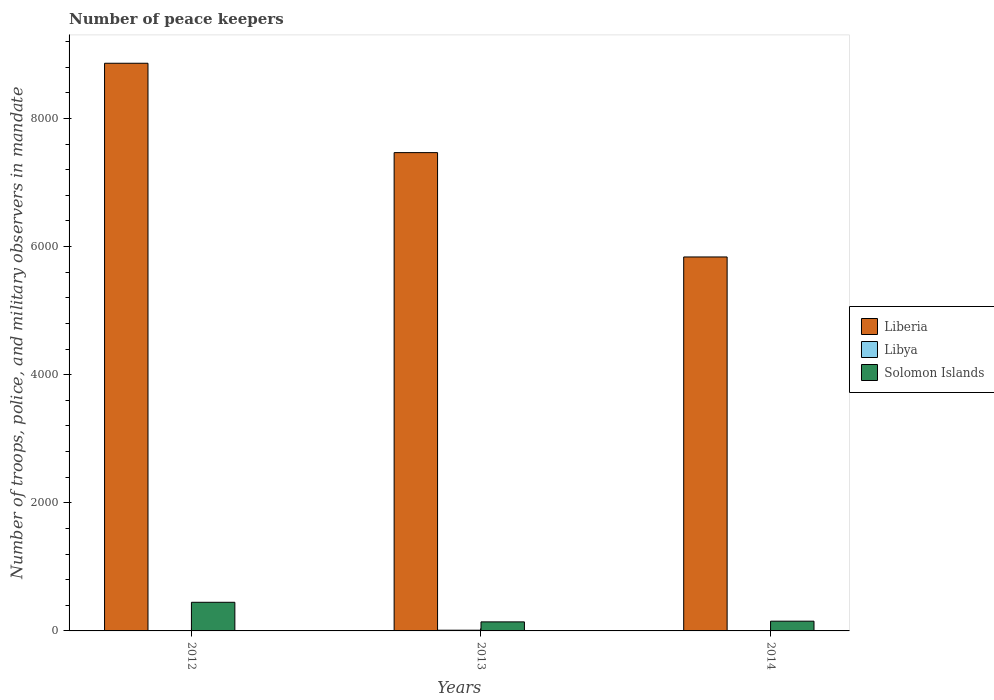How many different coloured bars are there?
Keep it short and to the point. 3. What is the number of peace keepers in in Solomon Islands in 2013?
Make the answer very short. 141. Across all years, what is the maximum number of peace keepers in in Solomon Islands?
Your answer should be very brief. 447. Across all years, what is the minimum number of peace keepers in in Libya?
Provide a succinct answer. 2. What is the total number of peace keepers in in Solomon Islands in the graph?
Your answer should be compact. 740. What is the difference between the number of peace keepers in in Liberia in 2012 and that in 2013?
Keep it short and to the point. 1395. What is the difference between the number of peace keepers in in Liberia in 2012 and the number of peace keepers in in Solomon Islands in 2013?
Give a very brief answer. 8721. What is the average number of peace keepers in in Solomon Islands per year?
Offer a terse response. 246.67. In the year 2012, what is the difference between the number of peace keepers in in Libya and number of peace keepers in in Liberia?
Keep it short and to the point. -8860. What is the ratio of the number of peace keepers in in Liberia in 2012 to that in 2013?
Offer a very short reply. 1.19. Is the number of peace keepers in in Libya in 2012 less than that in 2013?
Give a very brief answer. Yes. Is the difference between the number of peace keepers in in Libya in 2012 and 2013 greater than the difference between the number of peace keepers in in Liberia in 2012 and 2013?
Your answer should be very brief. No. What is the difference between the highest and the lowest number of peace keepers in in Solomon Islands?
Give a very brief answer. 306. In how many years, is the number of peace keepers in in Solomon Islands greater than the average number of peace keepers in in Solomon Islands taken over all years?
Provide a short and direct response. 1. Is the sum of the number of peace keepers in in Libya in 2013 and 2014 greater than the maximum number of peace keepers in in Solomon Islands across all years?
Provide a short and direct response. No. What does the 1st bar from the left in 2014 represents?
Give a very brief answer. Liberia. What does the 1st bar from the right in 2014 represents?
Your response must be concise. Solomon Islands. Is it the case that in every year, the sum of the number of peace keepers in in Liberia and number of peace keepers in in Libya is greater than the number of peace keepers in in Solomon Islands?
Offer a terse response. Yes. How many bars are there?
Offer a terse response. 9. Are all the bars in the graph horizontal?
Provide a succinct answer. No. How many years are there in the graph?
Offer a very short reply. 3. Does the graph contain any zero values?
Your answer should be compact. No. How many legend labels are there?
Offer a terse response. 3. What is the title of the graph?
Your answer should be very brief. Number of peace keepers. Does "Saudi Arabia" appear as one of the legend labels in the graph?
Offer a terse response. No. What is the label or title of the X-axis?
Offer a terse response. Years. What is the label or title of the Y-axis?
Ensure brevity in your answer.  Number of troops, police, and military observers in mandate. What is the Number of troops, police, and military observers in mandate in Liberia in 2012?
Make the answer very short. 8862. What is the Number of troops, police, and military observers in mandate of Solomon Islands in 2012?
Provide a short and direct response. 447. What is the Number of troops, police, and military observers in mandate in Liberia in 2013?
Your response must be concise. 7467. What is the Number of troops, police, and military observers in mandate of Solomon Islands in 2013?
Provide a short and direct response. 141. What is the Number of troops, police, and military observers in mandate in Liberia in 2014?
Offer a very short reply. 5838. What is the Number of troops, police, and military observers in mandate in Libya in 2014?
Your answer should be compact. 2. What is the Number of troops, police, and military observers in mandate in Solomon Islands in 2014?
Ensure brevity in your answer.  152. Across all years, what is the maximum Number of troops, police, and military observers in mandate in Liberia?
Make the answer very short. 8862. Across all years, what is the maximum Number of troops, police, and military observers in mandate of Solomon Islands?
Give a very brief answer. 447. Across all years, what is the minimum Number of troops, police, and military observers in mandate in Liberia?
Make the answer very short. 5838. Across all years, what is the minimum Number of troops, police, and military observers in mandate of Solomon Islands?
Offer a terse response. 141. What is the total Number of troops, police, and military observers in mandate in Liberia in the graph?
Provide a succinct answer. 2.22e+04. What is the total Number of troops, police, and military observers in mandate of Solomon Islands in the graph?
Your response must be concise. 740. What is the difference between the Number of troops, police, and military observers in mandate of Liberia in 2012 and that in 2013?
Give a very brief answer. 1395. What is the difference between the Number of troops, police, and military observers in mandate in Libya in 2012 and that in 2013?
Keep it short and to the point. -9. What is the difference between the Number of troops, police, and military observers in mandate in Solomon Islands in 2012 and that in 2013?
Make the answer very short. 306. What is the difference between the Number of troops, police, and military observers in mandate of Liberia in 2012 and that in 2014?
Your answer should be very brief. 3024. What is the difference between the Number of troops, police, and military observers in mandate in Solomon Islands in 2012 and that in 2014?
Your response must be concise. 295. What is the difference between the Number of troops, police, and military observers in mandate in Liberia in 2013 and that in 2014?
Make the answer very short. 1629. What is the difference between the Number of troops, police, and military observers in mandate in Libya in 2013 and that in 2014?
Offer a very short reply. 9. What is the difference between the Number of troops, police, and military observers in mandate of Solomon Islands in 2013 and that in 2014?
Offer a very short reply. -11. What is the difference between the Number of troops, police, and military observers in mandate of Liberia in 2012 and the Number of troops, police, and military observers in mandate of Libya in 2013?
Offer a terse response. 8851. What is the difference between the Number of troops, police, and military observers in mandate of Liberia in 2012 and the Number of troops, police, and military observers in mandate of Solomon Islands in 2013?
Provide a succinct answer. 8721. What is the difference between the Number of troops, police, and military observers in mandate of Libya in 2012 and the Number of troops, police, and military observers in mandate of Solomon Islands in 2013?
Keep it short and to the point. -139. What is the difference between the Number of troops, police, and military observers in mandate in Liberia in 2012 and the Number of troops, police, and military observers in mandate in Libya in 2014?
Keep it short and to the point. 8860. What is the difference between the Number of troops, police, and military observers in mandate of Liberia in 2012 and the Number of troops, police, and military observers in mandate of Solomon Islands in 2014?
Provide a succinct answer. 8710. What is the difference between the Number of troops, police, and military observers in mandate in Libya in 2012 and the Number of troops, police, and military observers in mandate in Solomon Islands in 2014?
Your answer should be compact. -150. What is the difference between the Number of troops, police, and military observers in mandate of Liberia in 2013 and the Number of troops, police, and military observers in mandate of Libya in 2014?
Provide a succinct answer. 7465. What is the difference between the Number of troops, police, and military observers in mandate in Liberia in 2013 and the Number of troops, police, and military observers in mandate in Solomon Islands in 2014?
Offer a terse response. 7315. What is the difference between the Number of troops, police, and military observers in mandate in Libya in 2013 and the Number of troops, police, and military observers in mandate in Solomon Islands in 2014?
Give a very brief answer. -141. What is the average Number of troops, police, and military observers in mandate in Liberia per year?
Give a very brief answer. 7389. What is the average Number of troops, police, and military observers in mandate in Solomon Islands per year?
Offer a terse response. 246.67. In the year 2012, what is the difference between the Number of troops, police, and military observers in mandate of Liberia and Number of troops, police, and military observers in mandate of Libya?
Offer a very short reply. 8860. In the year 2012, what is the difference between the Number of troops, police, and military observers in mandate of Liberia and Number of troops, police, and military observers in mandate of Solomon Islands?
Give a very brief answer. 8415. In the year 2012, what is the difference between the Number of troops, police, and military observers in mandate of Libya and Number of troops, police, and military observers in mandate of Solomon Islands?
Make the answer very short. -445. In the year 2013, what is the difference between the Number of troops, police, and military observers in mandate in Liberia and Number of troops, police, and military observers in mandate in Libya?
Offer a very short reply. 7456. In the year 2013, what is the difference between the Number of troops, police, and military observers in mandate in Liberia and Number of troops, police, and military observers in mandate in Solomon Islands?
Provide a succinct answer. 7326. In the year 2013, what is the difference between the Number of troops, police, and military observers in mandate of Libya and Number of troops, police, and military observers in mandate of Solomon Islands?
Give a very brief answer. -130. In the year 2014, what is the difference between the Number of troops, police, and military observers in mandate of Liberia and Number of troops, police, and military observers in mandate of Libya?
Give a very brief answer. 5836. In the year 2014, what is the difference between the Number of troops, police, and military observers in mandate in Liberia and Number of troops, police, and military observers in mandate in Solomon Islands?
Offer a very short reply. 5686. In the year 2014, what is the difference between the Number of troops, police, and military observers in mandate in Libya and Number of troops, police, and military observers in mandate in Solomon Islands?
Your response must be concise. -150. What is the ratio of the Number of troops, police, and military observers in mandate of Liberia in 2012 to that in 2013?
Your answer should be very brief. 1.19. What is the ratio of the Number of troops, police, and military observers in mandate of Libya in 2012 to that in 2013?
Keep it short and to the point. 0.18. What is the ratio of the Number of troops, police, and military observers in mandate in Solomon Islands in 2012 to that in 2013?
Ensure brevity in your answer.  3.17. What is the ratio of the Number of troops, police, and military observers in mandate of Liberia in 2012 to that in 2014?
Keep it short and to the point. 1.52. What is the ratio of the Number of troops, police, and military observers in mandate of Libya in 2012 to that in 2014?
Give a very brief answer. 1. What is the ratio of the Number of troops, police, and military observers in mandate in Solomon Islands in 2012 to that in 2014?
Offer a very short reply. 2.94. What is the ratio of the Number of troops, police, and military observers in mandate in Liberia in 2013 to that in 2014?
Give a very brief answer. 1.28. What is the ratio of the Number of troops, police, and military observers in mandate of Solomon Islands in 2013 to that in 2014?
Give a very brief answer. 0.93. What is the difference between the highest and the second highest Number of troops, police, and military observers in mandate in Liberia?
Provide a succinct answer. 1395. What is the difference between the highest and the second highest Number of troops, police, and military observers in mandate of Solomon Islands?
Offer a very short reply. 295. What is the difference between the highest and the lowest Number of troops, police, and military observers in mandate in Liberia?
Your answer should be very brief. 3024. What is the difference between the highest and the lowest Number of troops, police, and military observers in mandate of Solomon Islands?
Offer a terse response. 306. 